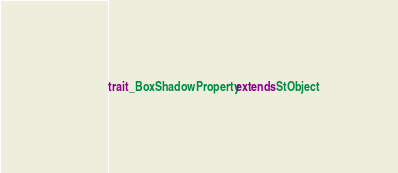Convert code to text. <code><loc_0><loc_0><loc_500><loc_500><_Scala_>
trait _BoxShadowProperty extends StObject
</code> 